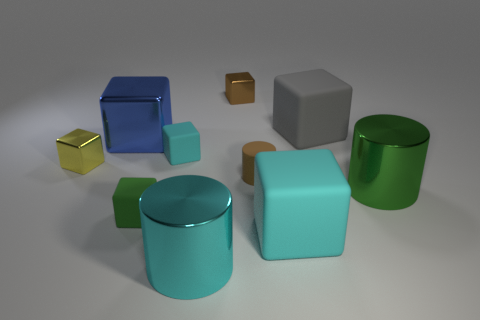Is there any other thing that has the same material as the small green object?
Provide a short and direct response. Yes. Do the yellow metallic block and the brown thing behind the big metal block have the same size?
Give a very brief answer. Yes. The cyan matte thing that is in front of the tiny cylinder has what shape?
Give a very brief answer. Cube. There is a tiny matte block behind the tiny metal block that is in front of the blue shiny thing; what is its color?
Ensure brevity in your answer.  Cyan. There is a large shiny thing that is the same shape as the big gray matte thing; what color is it?
Keep it short and to the point. Blue. How many small shiny blocks have the same color as the tiny cylinder?
Your response must be concise. 1. Is the color of the rubber cylinder the same as the big shiny cylinder in front of the green shiny thing?
Your answer should be very brief. No. There is a shiny object that is on the left side of the brown rubber cylinder and in front of the small brown cylinder; what is its shape?
Your response must be concise. Cylinder. There is a brown object in front of the yellow block that is behind the brown thing that is in front of the small cyan object; what is it made of?
Give a very brief answer. Rubber. Is the number of large green metal objects on the left side of the large cyan matte block greater than the number of big gray matte blocks in front of the gray cube?
Offer a terse response. No. 